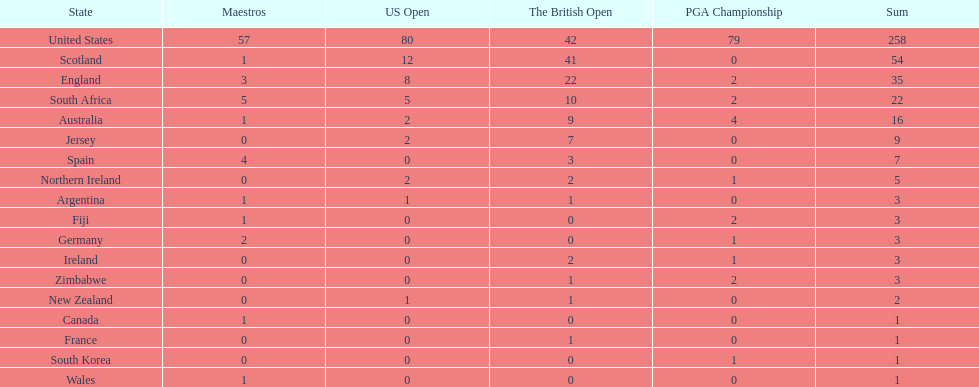How many countries have produced the same number of championship golfers as canada? 3. 